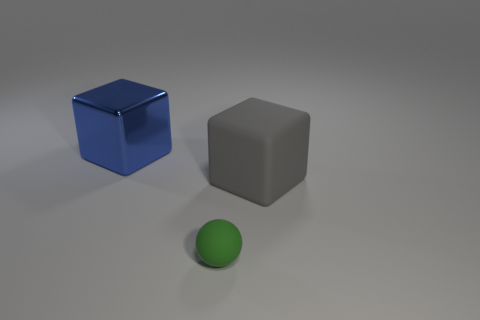Subtract all red spheres. Subtract all green cubes. How many spheres are left? 1 Add 3 large gray matte blocks. How many objects exist? 6 Subtract all spheres. How many objects are left? 2 Subtract all green matte balls. Subtract all gray things. How many objects are left? 1 Add 1 tiny rubber balls. How many tiny rubber balls are left? 2 Add 2 green spheres. How many green spheres exist? 3 Subtract 1 blue blocks. How many objects are left? 2 